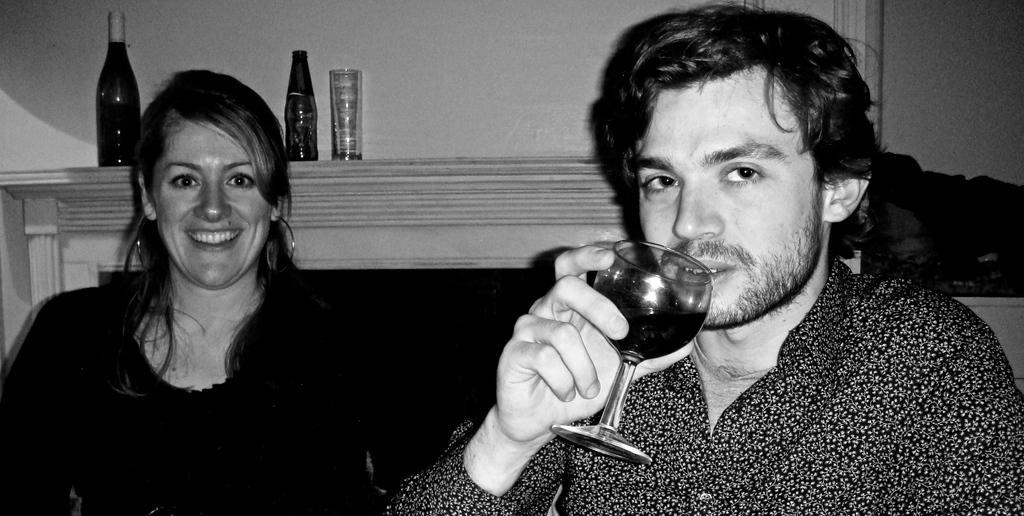How would you summarize this image in a sentence or two? In this image there are 2 persons , and the background there is bottle , glass , fireplace. 